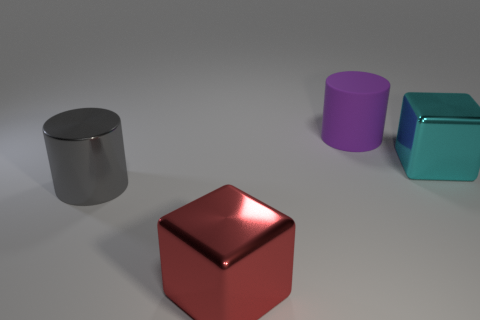Add 1 purple cylinders. How many objects exist? 5 Subtract 1 cylinders. How many cylinders are left? 1 Subtract all purple cylinders. How many cylinders are left? 1 Subtract all tiny gray metallic cylinders. Subtract all big things. How many objects are left? 0 Add 3 large cylinders. How many large cylinders are left? 5 Add 4 tiny gray rubber blocks. How many tiny gray rubber blocks exist? 4 Subtract 0 brown spheres. How many objects are left? 4 Subtract all gray cylinders. Subtract all green spheres. How many cylinders are left? 1 